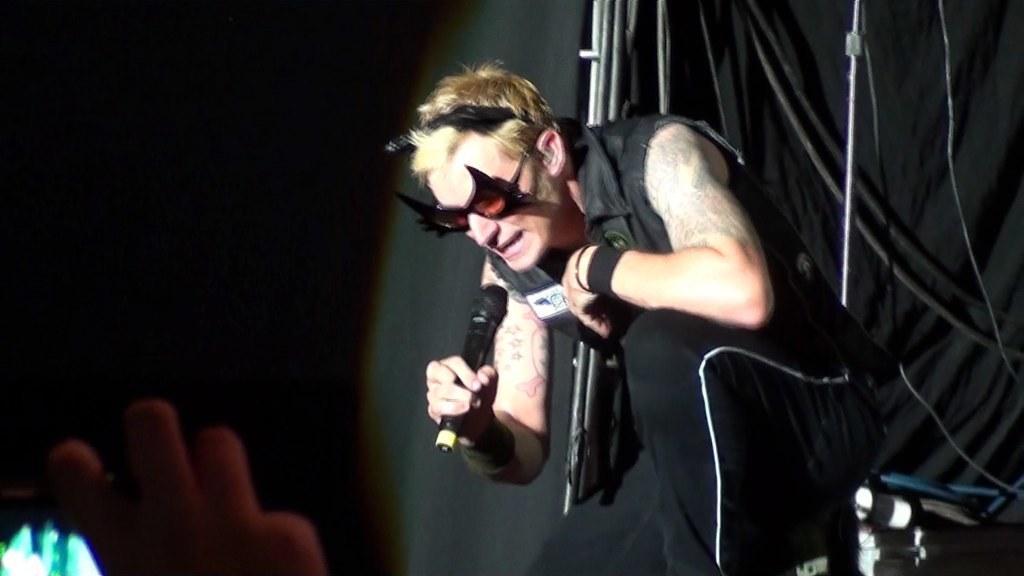Can you describe this image briefly? In this image we can see a person holding a mic and in the background there are few rods and a black color curtain and in the left side we can see a person´s hand. 